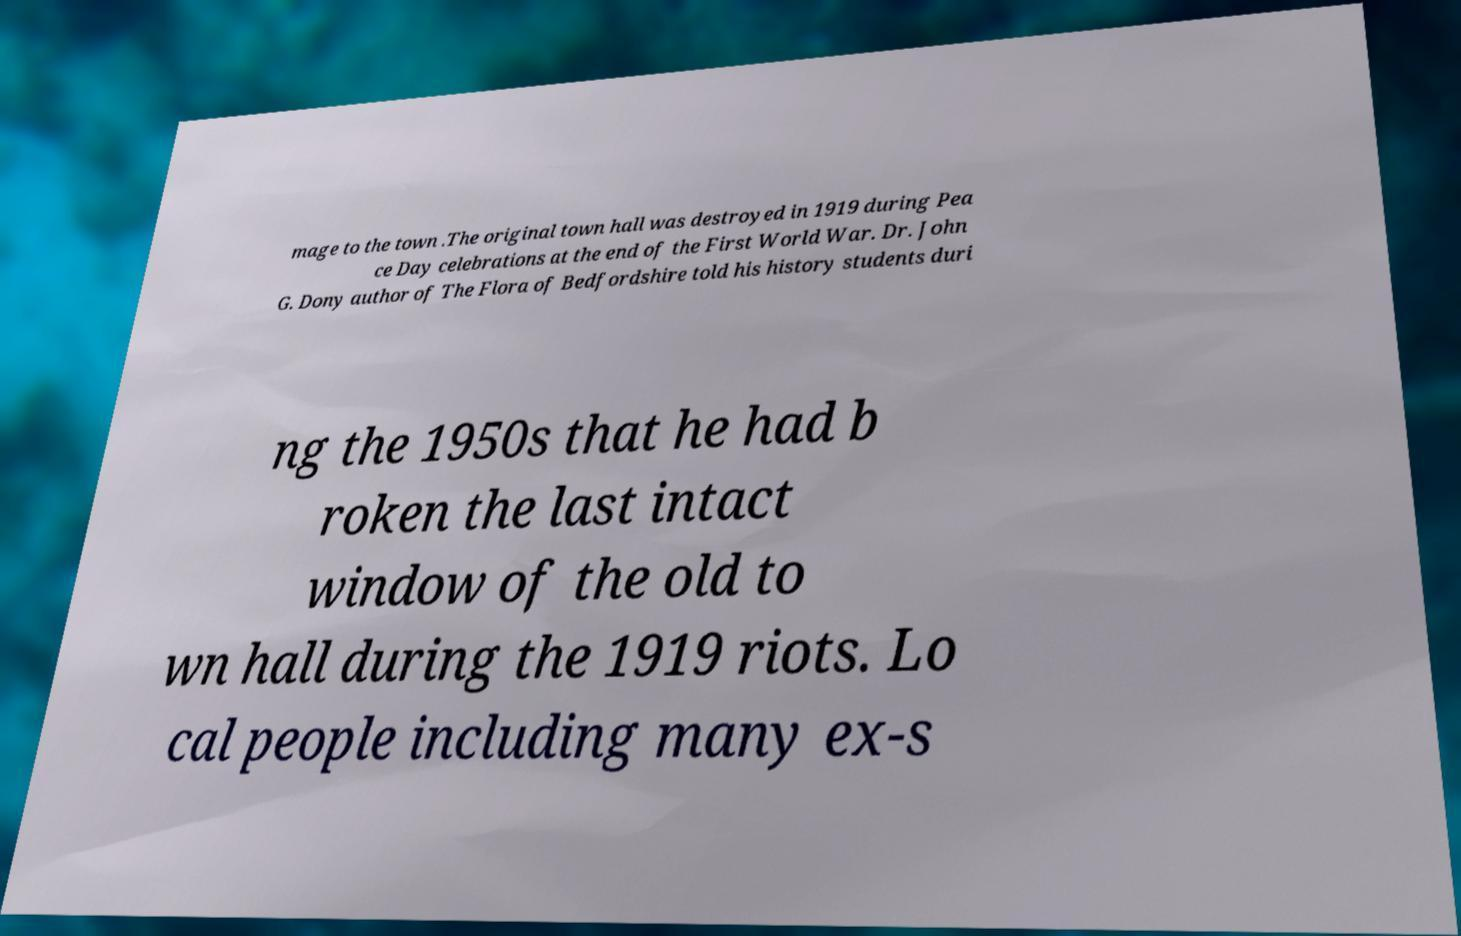There's text embedded in this image that I need extracted. Can you transcribe it verbatim? mage to the town .The original town hall was destroyed in 1919 during Pea ce Day celebrations at the end of the First World War. Dr. John G. Dony author of The Flora of Bedfordshire told his history students duri ng the 1950s that he had b roken the last intact window of the old to wn hall during the 1919 riots. Lo cal people including many ex-s 